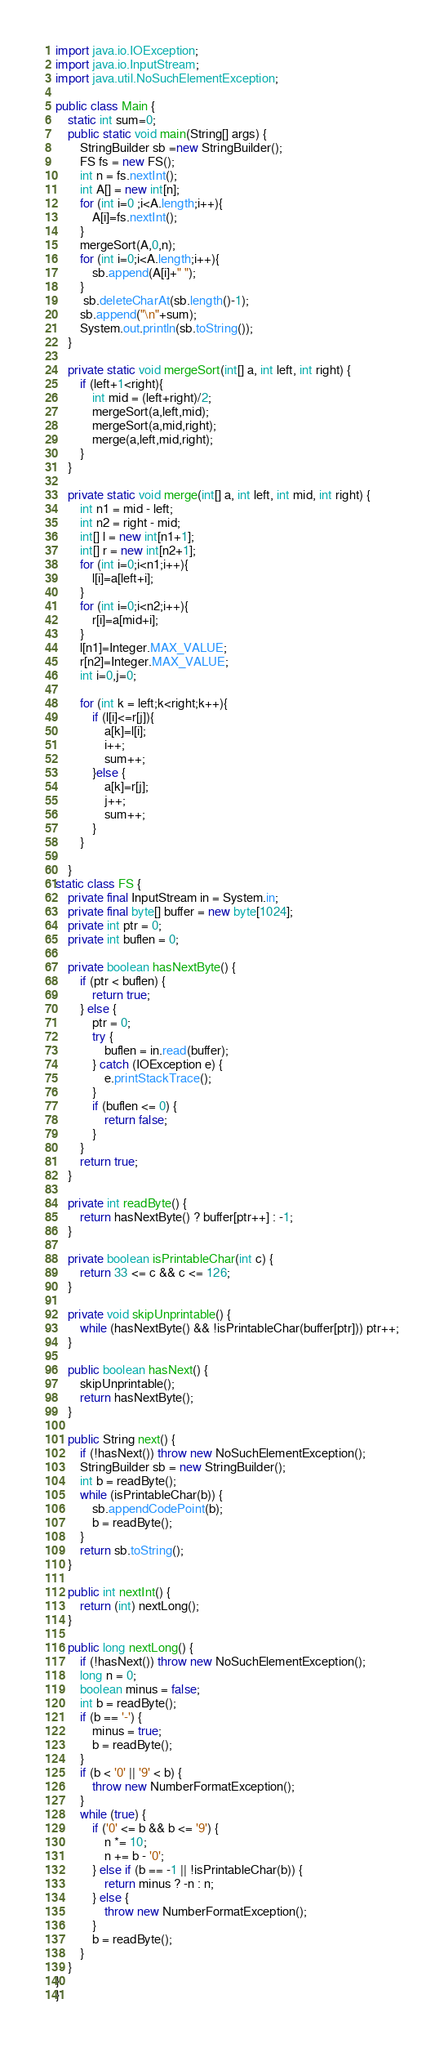Convert code to text. <code><loc_0><loc_0><loc_500><loc_500><_Java_>import java.io.IOException;
import java.io.InputStream;
import java.util.NoSuchElementException;

public class Main {
    static int sum=0;
    public static void main(String[] args) {
        StringBuilder sb =new StringBuilder();
        FS fs = new FS();
        int n = fs.nextInt();
        int A[] = new int[n];
        for (int i=0 ;i<A.length;i++){
            A[i]=fs.nextInt();
        }
        mergeSort(A,0,n);
        for (int i=0;i<A.length;i++){
            sb.append(A[i]+" ");
        }
         sb.deleteCharAt(sb.length()-1);
        sb.append("\n"+sum);
        System.out.println(sb.toString());
    }

    private static void mergeSort(int[] a, int left, int right) {
        if (left+1<right){
            int mid = (left+right)/2;
            mergeSort(a,left,mid);
            mergeSort(a,mid,right);
            merge(a,left,mid,right);
        }
    }

    private static void merge(int[] a, int left, int mid, int right) {
        int n1 = mid - left;
        int n2 = right - mid;
        int[] l = new int[n1+1];
        int[] r = new int[n2+1];
        for (int i=0;i<n1;i++){
            l[i]=a[left+i];
        }
        for (int i=0;i<n2;i++){
            r[i]=a[mid+i];
        }
        l[n1]=Integer.MAX_VALUE;
        r[n2]=Integer.MAX_VALUE;
        int i=0,j=0;

        for (int k = left;k<right;k++){
            if (l[i]<=r[j]){
                a[k]=l[i];
                i++;
                sum++;
            }else {
                a[k]=r[j];
                j++;
                sum++;
            }
        }

    }
static class FS {
    private final InputStream in = System.in;
    private final byte[] buffer = new byte[1024];
    private int ptr = 0;
    private int buflen = 0;

    private boolean hasNextByte() {
        if (ptr < buflen) {
            return true;
        } else {
            ptr = 0;
            try {
                buflen = in.read(buffer);
            } catch (IOException e) {
                e.printStackTrace();
            }
            if (buflen <= 0) {
                return false;
            }
        }
        return true;
    }

    private int readByte() {
        return hasNextByte() ? buffer[ptr++] : -1;
    }

    private boolean isPrintableChar(int c) {
        return 33 <= c && c <= 126;
    }

    private void skipUnprintable() {
        while (hasNextByte() && !isPrintableChar(buffer[ptr])) ptr++;
    }

    public boolean hasNext() {
        skipUnprintable();
        return hasNextByte();
    }

    public String next() {
        if (!hasNext()) throw new NoSuchElementException();
        StringBuilder sb = new StringBuilder();
        int b = readByte();
        while (isPrintableChar(b)) {
            sb.appendCodePoint(b);
            b = readByte();
        }
        return sb.toString();
    }

    public int nextInt() {
        return (int) nextLong();
    }

    public long nextLong() {
        if (!hasNext()) throw new NoSuchElementException();
        long n = 0;
        boolean minus = false;
        int b = readByte();
        if (b == '-') {
            minus = true;
            b = readByte();
        }
        if (b < '0' || '9' < b) {
            throw new NumberFormatException();
        }
        while (true) {
            if ('0' <= b && b <= '9') {
                n *= 10;
                n += b - '0';
            } else if (b == -1 || !isPrintableChar(b)) {
                return minus ? -n : n;
            } else {
                throw new NumberFormatException();
            }
            b = readByte();
        }
    }
}
}
</code> 